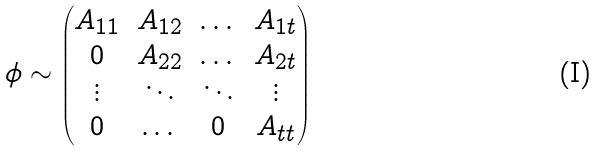<formula> <loc_0><loc_0><loc_500><loc_500>\phi \sim \begin{pmatrix} A _ { 1 1 } & A _ { 1 2 } & \dots & A _ { 1 t } \\ 0 & A _ { 2 2 } & \dots & A _ { 2 t } \\ \vdots & \ddots & \ddots & \vdots \\ 0 & \dots & 0 & A _ { t t } \end{pmatrix}</formula> 